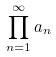Convert formula to latex. <formula><loc_0><loc_0><loc_500><loc_500>\prod _ { n = 1 } ^ { \infty } a _ { n }</formula> 